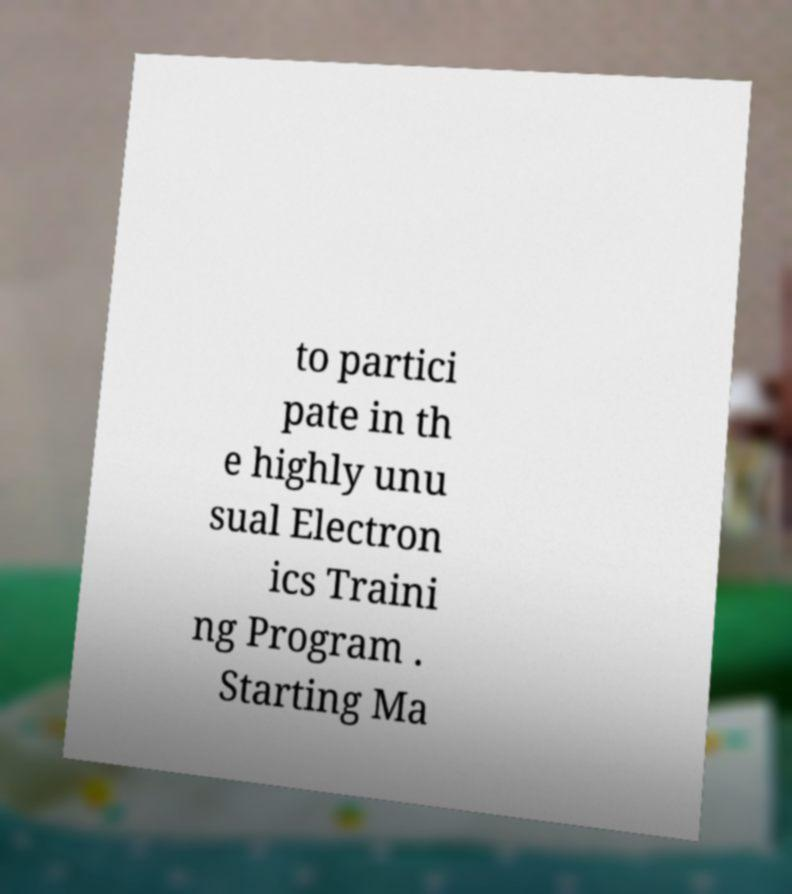Could you assist in decoding the text presented in this image and type it out clearly? to partici pate in th e highly unu sual Electron ics Traini ng Program . Starting Ma 